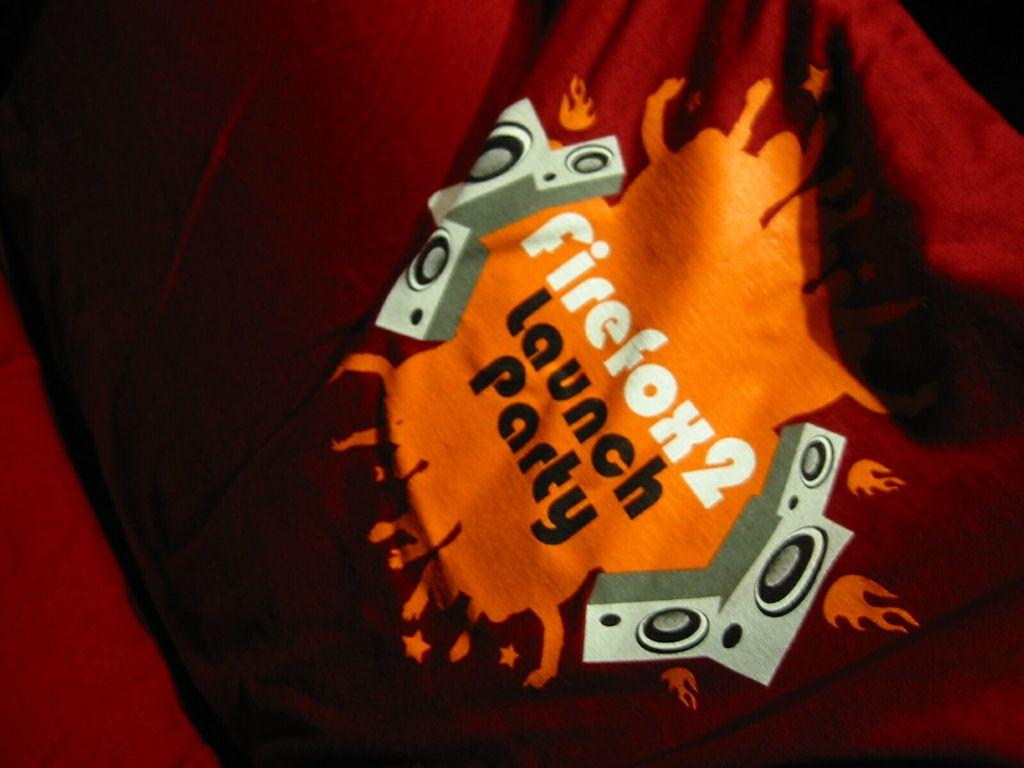What elements are present in the image? There is text and images in the image. What is the color of the cloth on which the text and images are placed? The text and images are on a red color cloth. What type of silver material is used to make the ball in the image? There is no ball present in the image, and therefore no such material can be identified. Can you tell me how many zippers are visible in the image? There are no zippers present in the image. 